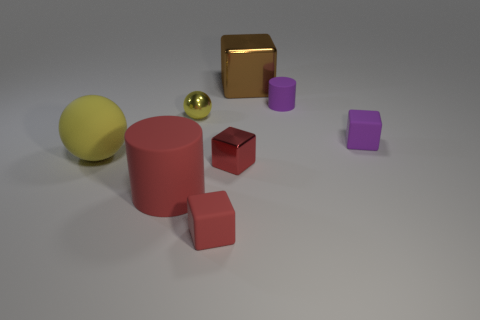Subtract all brown cylinders. How many red blocks are left? 2 Subtract all small metal blocks. How many blocks are left? 3 Add 1 purple matte cubes. How many objects exist? 9 Subtract all brown cubes. How many cubes are left? 3 Subtract all green blocks. Subtract all yellow cylinders. How many blocks are left? 4 Subtract all spheres. How many objects are left? 6 Add 1 rubber objects. How many rubber objects exist? 6 Subtract 0 gray balls. How many objects are left? 8 Subtract all cyan metallic cylinders. Subtract all shiny things. How many objects are left? 5 Add 1 metallic blocks. How many metallic blocks are left? 3 